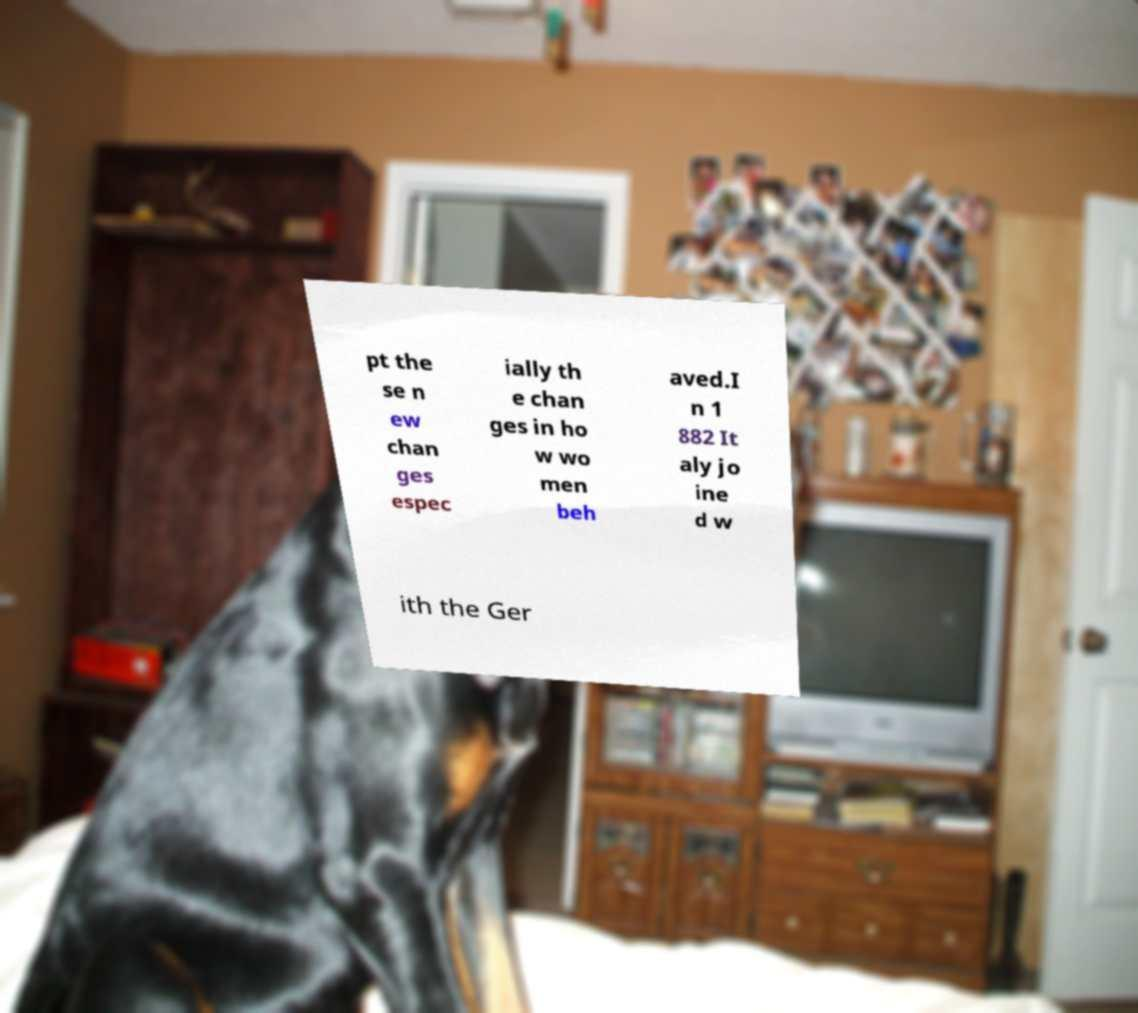Please read and relay the text visible in this image. What does it say? pt the se n ew chan ges espec ially th e chan ges in ho w wo men beh aved.I n 1 882 It aly jo ine d w ith the Ger 